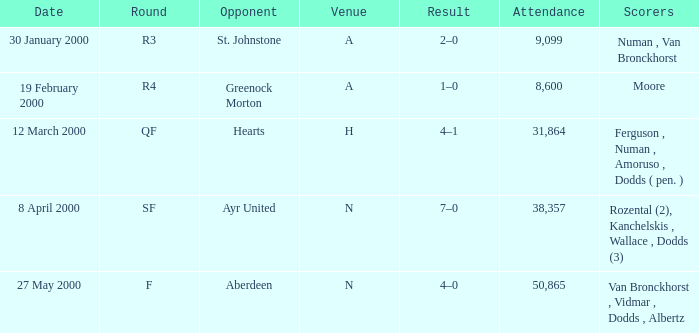What venue was on 27 May 2000? N. 